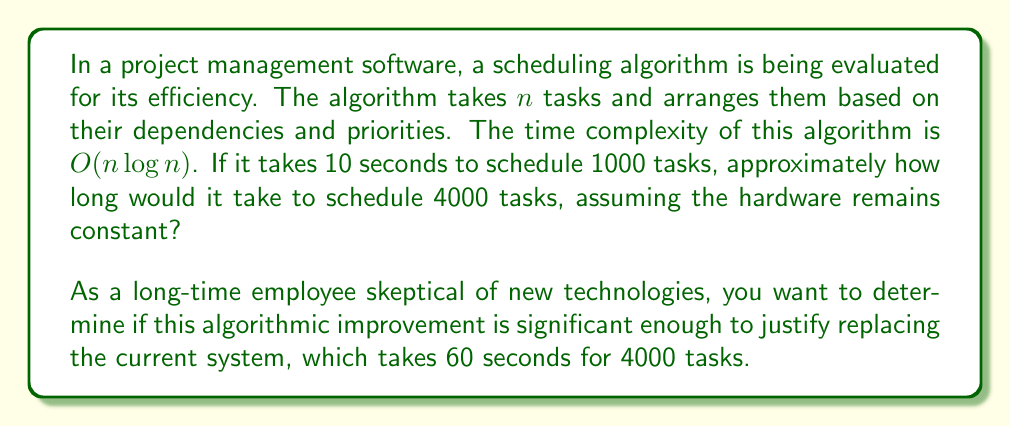Can you answer this question? To solve this problem, we need to understand the time complexity and how it scales with input size. The given algorithm has a time complexity of $O(n \log n)$.

Let's break it down step-by-step:

1) We know that for 1000 tasks, the time taken is 10 seconds.
   Let's call the constant factor $k$, so:
   $10 = k * 1000 * \log(1000)$

2) Solve for $k$:
   $k = \frac{10}{1000 * \log(1000)} \approx 0.001$

3) Now, for 4000 tasks, the time would be:
   $T = k * 4000 * \log(4000)$

4) Substituting the value of $k$:
   $T \approx 0.001 * 4000 * \log(4000)$

5) Calculating:
   $T \approx 0.001 * 4000 * 3.6 \approx 14.4$ seconds

6) Comparing with the current system:
   New algorithm: ~14.4 seconds
   Current system: 60 seconds

This shows a significant improvement in efficiency, with the new algorithm taking less than a quarter of the time of the current system for 4000 tasks.
Answer: The new scheduling algorithm would take approximately 14.4 seconds to schedule 4000 tasks, which is significantly faster than the current system's 60 seconds. 